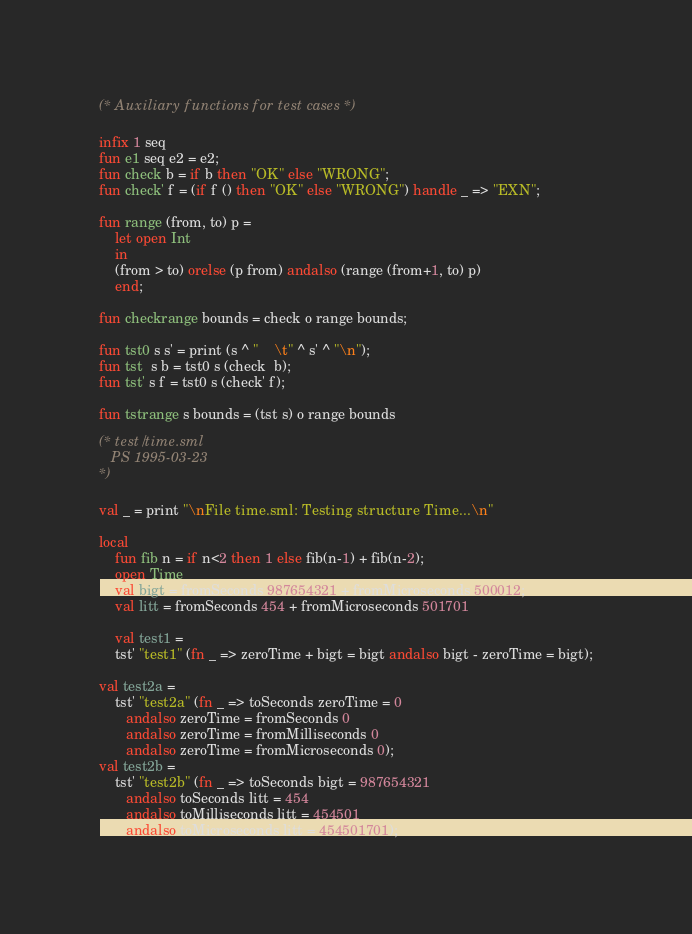Convert code to text. <code><loc_0><loc_0><loc_500><loc_500><_SML_>(* Auxiliary functions for test cases *)

infix 1 seq
fun e1 seq e2 = e2;
fun check b = if b then "OK" else "WRONG";
fun check' f = (if f () then "OK" else "WRONG") handle _ => "EXN";

fun range (from, to) p = 
    let open Int 
    in
	(from > to) orelse (p from) andalso (range (from+1, to) p)
    end;

fun checkrange bounds = check o range bounds;

fun tst0 s s' = print (s ^ "    \t" ^ s' ^ "\n");
fun tst  s b = tst0 s (check  b);
fun tst' s f = tst0 s (check' f);

fun tstrange s bounds = (tst s) o range bounds  

(* test/time.sml
   PS 1995-03-23
*)

val _ = print "\nFile time.sml: Testing structure Time...\n"

local 
    fun fib n = if n<2 then 1 else fib(n-1) + fib(n-2);
    open Time
    val bigt = fromSeconds 987654321 + fromMicroseconds 500012;
    val litt = fromSeconds 454 + fromMicroseconds 501701

    val test1 = 
    tst' "test1" (fn _ => zeroTime + bigt = bigt andalso bigt - zeroTime = bigt);

val test2a = 
    tst' "test2a" (fn _ => toSeconds zeroTime = 0
	   andalso zeroTime = fromSeconds 0
	   andalso zeroTime = fromMilliseconds 0
	   andalso zeroTime = fromMicroseconds 0);
val test2b = 
    tst' "test2b" (fn _ => toSeconds bigt = 987654321
	   andalso toSeconds litt = 454
	   andalso toMilliseconds litt = 454501
	   andalso toMicroseconds litt = 454501701);</code> 